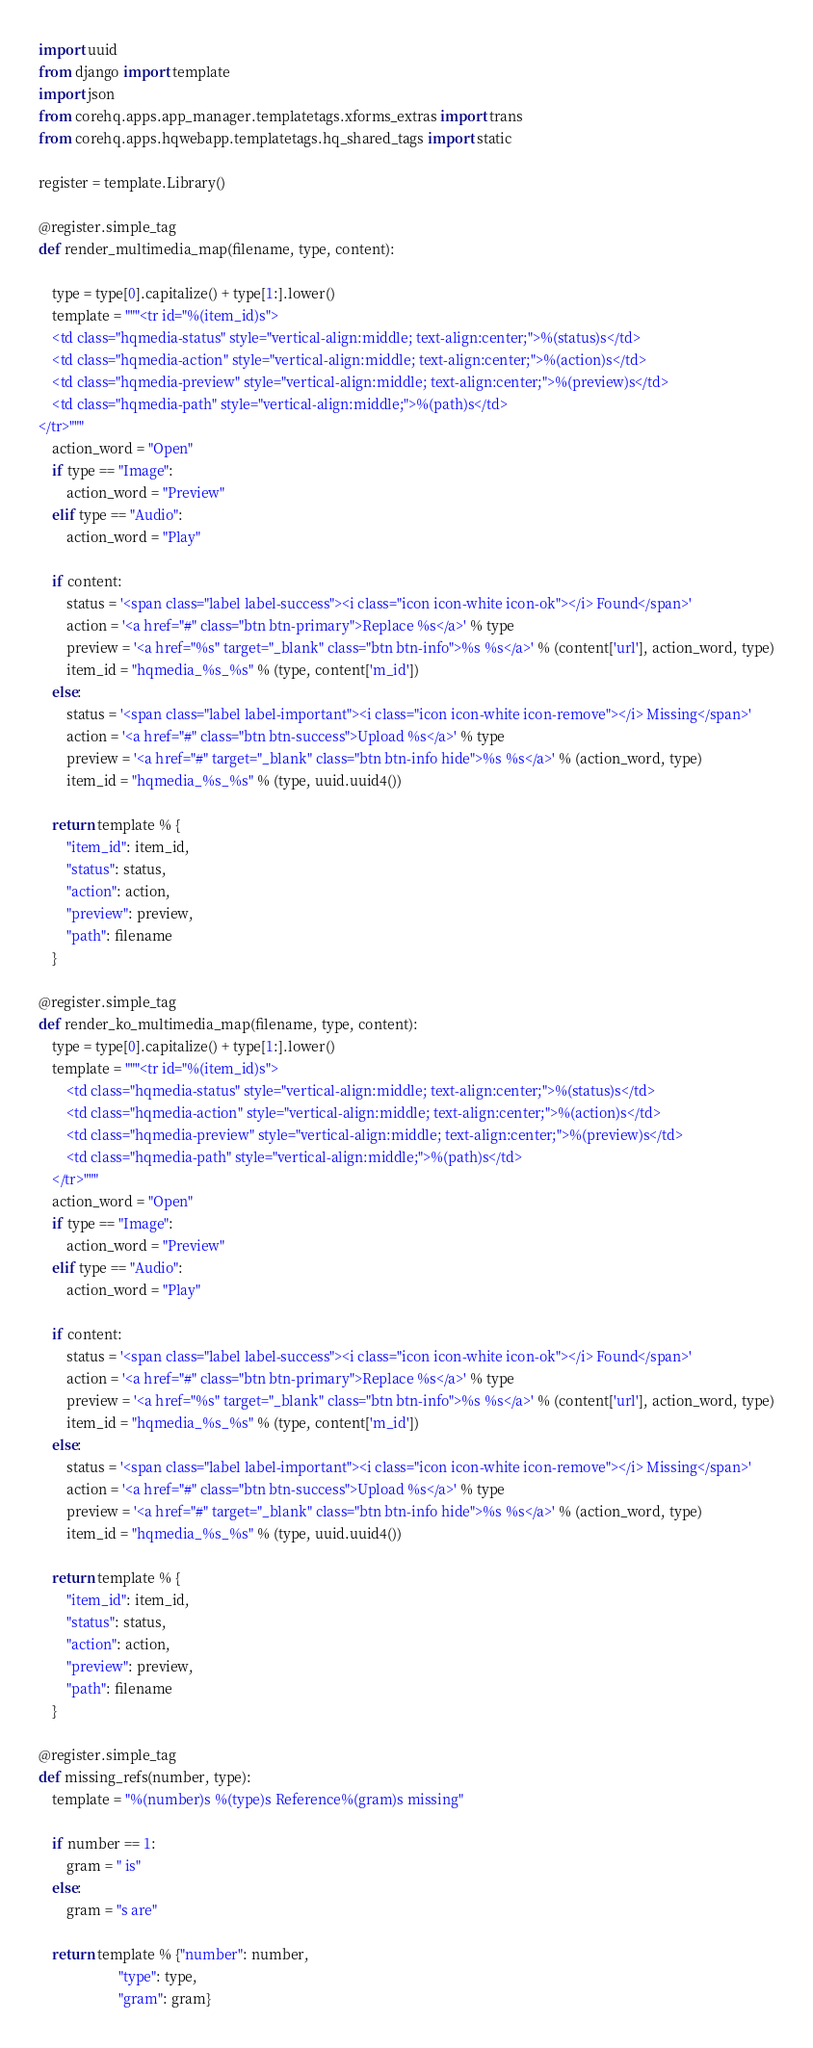Convert code to text. <code><loc_0><loc_0><loc_500><loc_500><_Python_>import uuid
from django import template
import json
from corehq.apps.app_manager.templatetags.xforms_extras import trans
from corehq.apps.hqwebapp.templatetags.hq_shared_tags import static

register = template.Library()

@register.simple_tag
def render_multimedia_map(filename, type, content):

    type = type[0].capitalize() + type[1:].lower()
    template = """<tr id="%(item_id)s">
    <td class="hqmedia-status" style="vertical-align:middle; text-align:center;">%(status)s</td>
    <td class="hqmedia-action" style="vertical-align:middle; text-align:center;">%(action)s</td>
    <td class="hqmedia-preview" style="vertical-align:middle; text-align:center;">%(preview)s</td>
    <td class="hqmedia-path" style="vertical-align:middle;">%(path)s</td>
</tr>"""
    action_word = "Open"
    if type == "Image":
        action_word = "Preview"
    elif type == "Audio":
        action_word = "Play"

    if content:
        status = '<span class="label label-success"><i class="icon icon-white icon-ok"></i> Found</span>'
        action = '<a href="#" class="btn btn-primary">Replace %s</a>' % type
        preview = '<a href="%s" target="_blank" class="btn btn-info">%s %s</a>' % (content['url'], action_word, type)
        item_id = "hqmedia_%s_%s" % (type, content['m_id'])
    else:
        status = '<span class="label label-important"><i class="icon icon-white icon-remove"></i> Missing</span>'
        action = '<a href="#" class="btn btn-success">Upload %s</a>' % type
        preview = '<a href="#" target="_blank" class="btn btn-info hide">%s %s</a>' % (action_word, type)
        item_id = "hqmedia_%s_%s" % (type, uuid.uuid4())

    return template % {
        "item_id": item_id,
        "status": status,
        "action": action,
        "preview": preview,
        "path": filename
    }

@register.simple_tag
def render_ko_multimedia_map(filename, type, content):
    type = type[0].capitalize() + type[1:].lower()
    template = """<tr id="%(item_id)s">
        <td class="hqmedia-status" style="vertical-align:middle; text-align:center;">%(status)s</td>
        <td class="hqmedia-action" style="vertical-align:middle; text-align:center;">%(action)s</td>
        <td class="hqmedia-preview" style="vertical-align:middle; text-align:center;">%(preview)s</td>
        <td class="hqmedia-path" style="vertical-align:middle;">%(path)s</td>
    </tr>"""
    action_word = "Open"
    if type == "Image":
        action_word = "Preview"
    elif type == "Audio":
        action_word = "Play"

    if content:
        status = '<span class="label label-success"><i class="icon icon-white icon-ok"></i> Found</span>'
        action = '<a href="#" class="btn btn-primary">Replace %s</a>' % type
        preview = '<a href="%s" target="_blank" class="btn btn-info">%s %s</a>' % (content['url'], action_word, type)
        item_id = "hqmedia_%s_%s" % (type, content['m_id'])
    else:
        status = '<span class="label label-important"><i class="icon icon-white icon-remove"></i> Missing</span>'
        action = '<a href="#" class="btn btn-success">Upload %s</a>' % type
        preview = '<a href="#" target="_blank" class="btn btn-info hide">%s %s</a>' % (action_word, type)
        item_id = "hqmedia_%s_%s" % (type, uuid.uuid4())

    return template % {
        "item_id": item_id,
        "status": status,
        "action": action,
        "preview": preview,
        "path": filename
    }

@register.simple_tag
def missing_refs(number, type):
    template = "%(number)s %(type)s Reference%(gram)s missing"

    if number == 1:
        gram = " is"
    else:
        gram = "s are"

    return template % {"number": number,
                       "type": type,
                       "gram": gram}</code> 